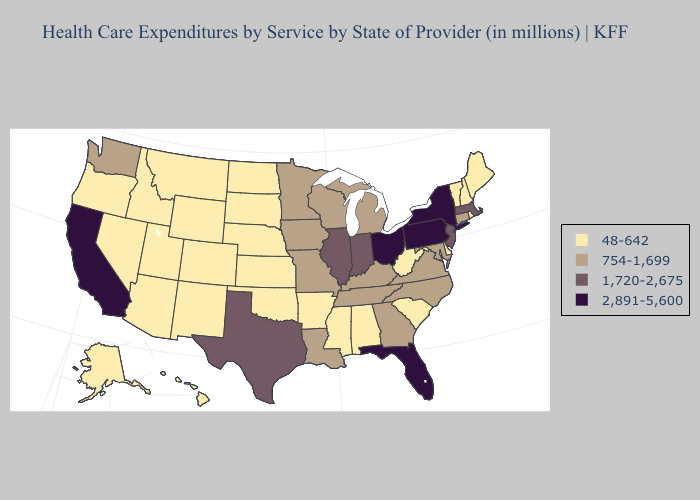Among the states that border Wisconsin , does Illinois have the highest value?
Short answer required. Yes. Does Georgia have the lowest value in the USA?
Short answer required. No. What is the lowest value in the South?
Answer briefly. 48-642. What is the value of Tennessee?
Quick response, please. 754-1,699. Name the states that have a value in the range 2,891-5,600?
Quick response, please. California, Florida, New York, Ohio, Pennsylvania. Name the states that have a value in the range 1,720-2,675?
Give a very brief answer. Illinois, Indiana, Massachusetts, New Jersey, Texas. Among the states that border Mississippi , does Tennessee have the highest value?
Quick response, please. Yes. Is the legend a continuous bar?
Short answer required. No. Name the states that have a value in the range 1,720-2,675?
Short answer required. Illinois, Indiana, Massachusetts, New Jersey, Texas. Name the states that have a value in the range 1,720-2,675?
Concise answer only. Illinois, Indiana, Massachusetts, New Jersey, Texas. Does the map have missing data?
Write a very short answer. No. What is the lowest value in states that border South Dakota?
Keep it brief. 48-642. Does Colorado have the same value as Nevada?
Concise answer only. Yes. Among the states that border Delaware , which have the lowest value?
Quick response, please. Maryland. What is the value of Maryland?
Quick response, please. 754-1,699. 